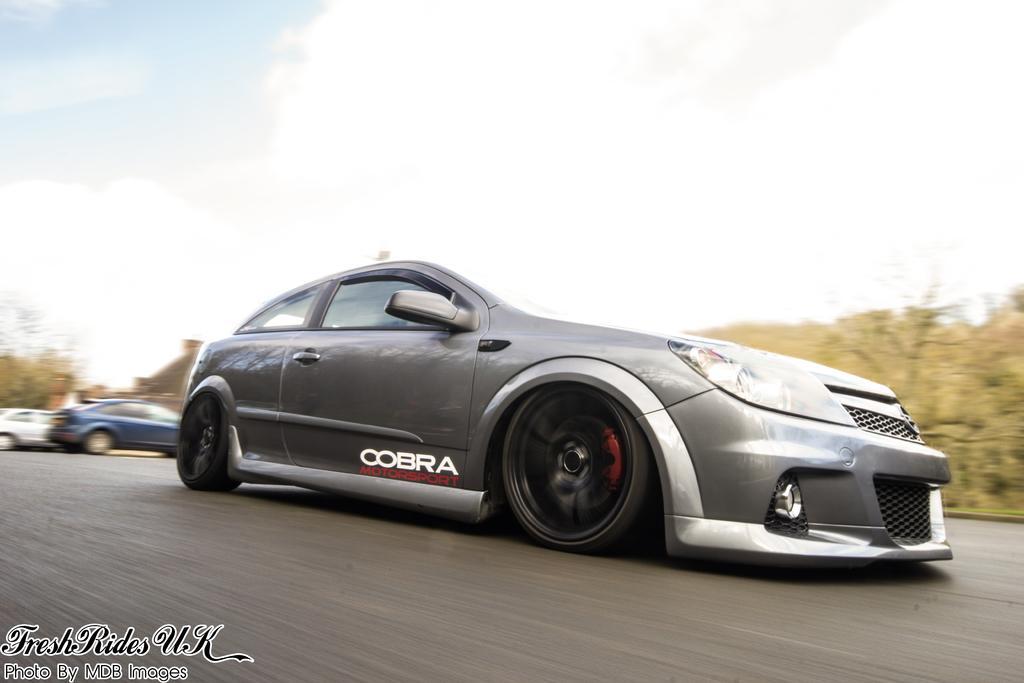In one or two sentences, can you explain what this image depicts? In the image there is a car going on road and behind there are two cars, in the background there are trees and above its sky with clouds. 